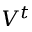Convert formula to latex. <formula><loc_0><loc_0><loc_500><loc_500>V ^ { t }</formula> 